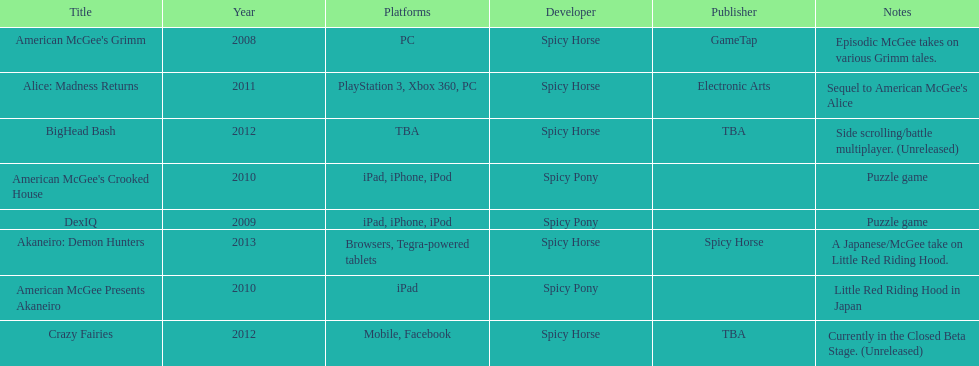What was the only game published by electronic arts? Alice: Madness Returns. 